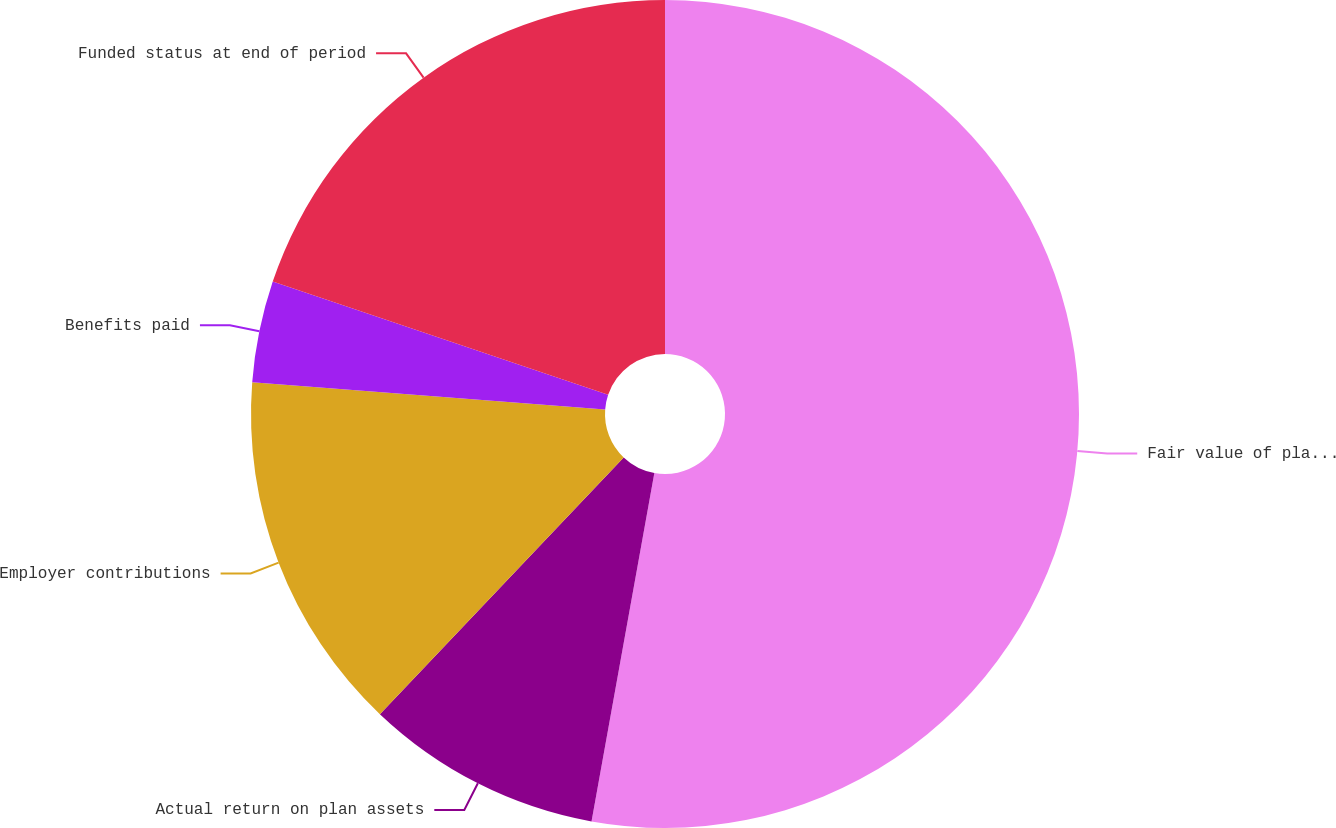Convert chart to OTSL. <chart><loc_0><loc_0><loc_500><loc_500><pie_chart><fcel>Fair value of plan assets at<fcel>Actual return on plan assets<fcel>Employer contributions<fcel>Benefits paid<fcel>Funded status at end of period<nl><fcel>52.84%<fcel>9.25%<fcel>14.13%<fcel>3.96%<fcel>19.82%<nl></chart> 